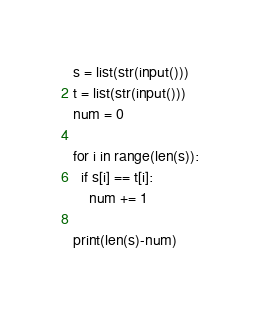<code> <loc_0><loc_0><loc_500><loc_500><_Python_>s = list(str(input()))
t = list(str(input()))
num = 0

for i in range(len(s)):
  if s[i] == t[i]:
    num += 1
    
print(len(s)-num)</code> 